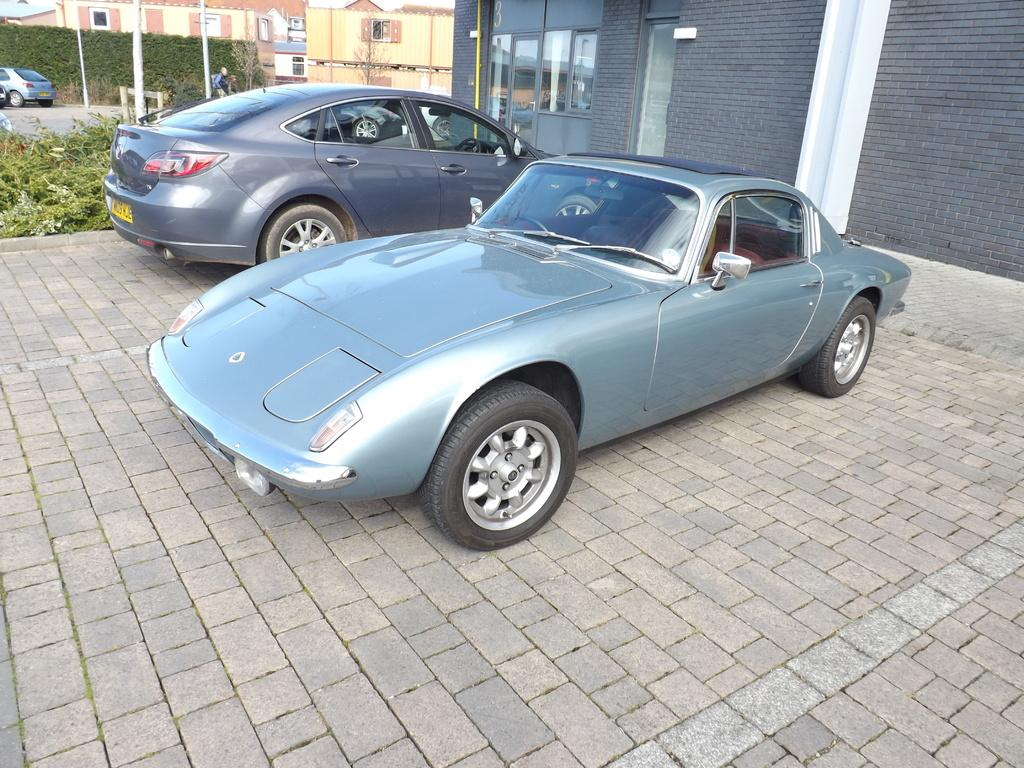How many cars are visible on the road in the image? There are two cars on the road in the image. What is located behind the cars? The cars are in front of a building. What can be seen behind the building? There are plants behind the building. What is visible in the background of the image? There are buildings and plants in the background of the image. Can you tell me how many seeds are scattered on the sidewalk in the image? There is no mention of seeds or a sidewalk in the image; it features two cars on the road in front of a building, with plants and buildings visible in the background. 